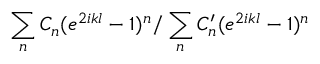<formula> <loc_0><loc_0><loc_500><loc_500>\sum _ { n } C _ { n } ( e ^ { 2 i k l } - 1 ) ^ { n } / \sum _ { n } C _ { n } ^ { \prime } ( e ^ { 2 i k l } - 1 ) ^ { n }</formula> 